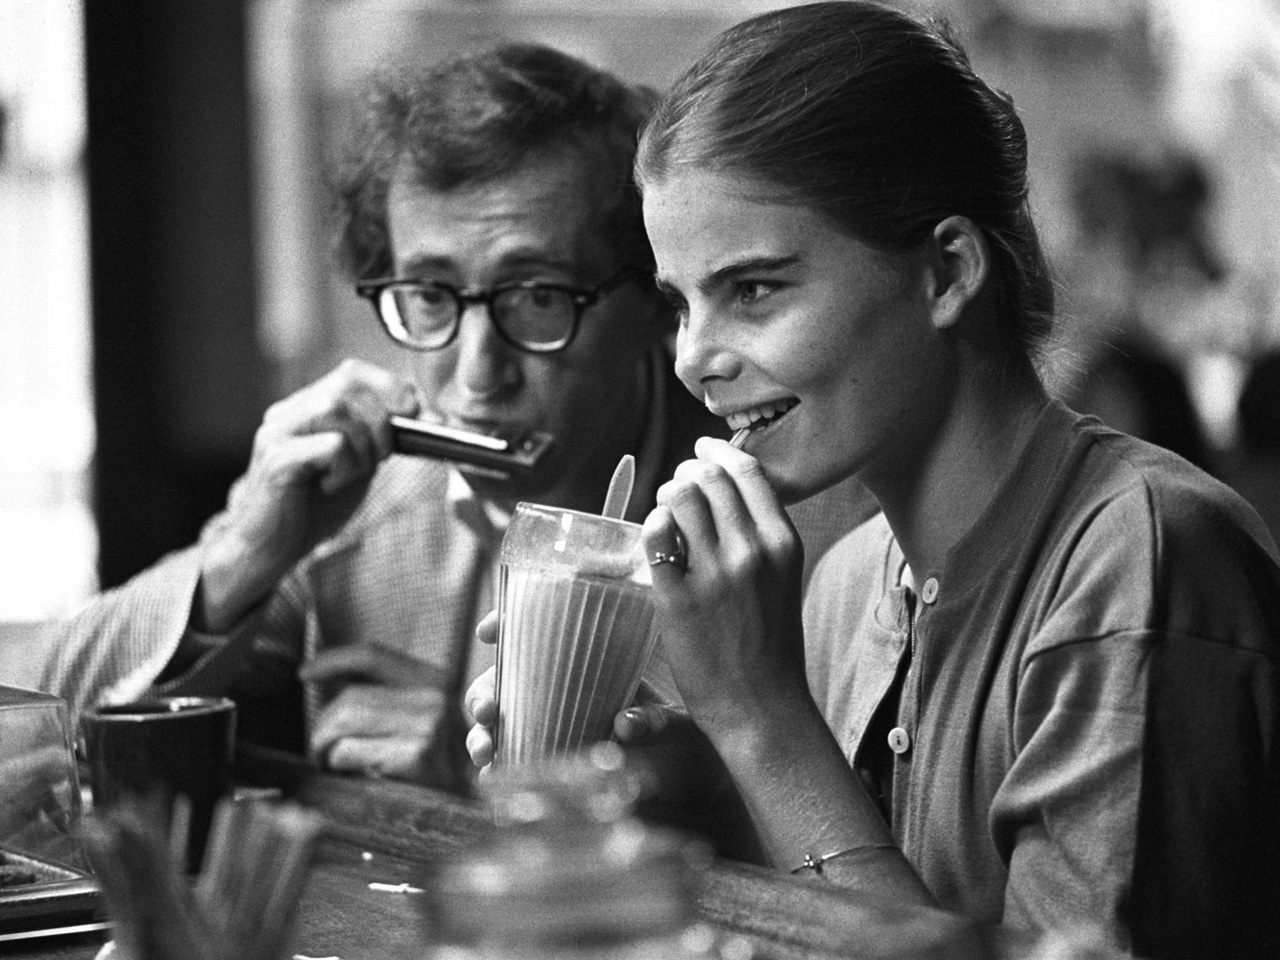How do you think these two individuals ended up in this moment? Perhaps these two individuals, seeking a moment of relaxation and enjoyment, crossed paths at this charming cafe. They could have struck up a conversation about their shared love for music, leading to the person on the left spontaneously deciding to play the harmonica, infusing the ambiance with a melodious charm. Do you think they are good friends, or maybe it's a first meeting? It’s likely they share a warm friendship, given the relaxed and comfortable nature of their interaction. The way they are absorbed in their activities suggests a familiarity and ease often found between good friends. However, there’s also a possibility that this charming scene captures the beginnings of a new friendship, sparked by a shared moment of spontaneity and music. Imagine they are planning a creative project together. What could it be? Imagining these two individuals planning a creative project together, it’s easy to envision them collaborating on a film or a music video, combining the person on the left’s musical talent with the storytelling and expressive skill of the person on the right. Their project could explore the themes of everyday life, infusing it with poetic realism and heartfelt moments. 